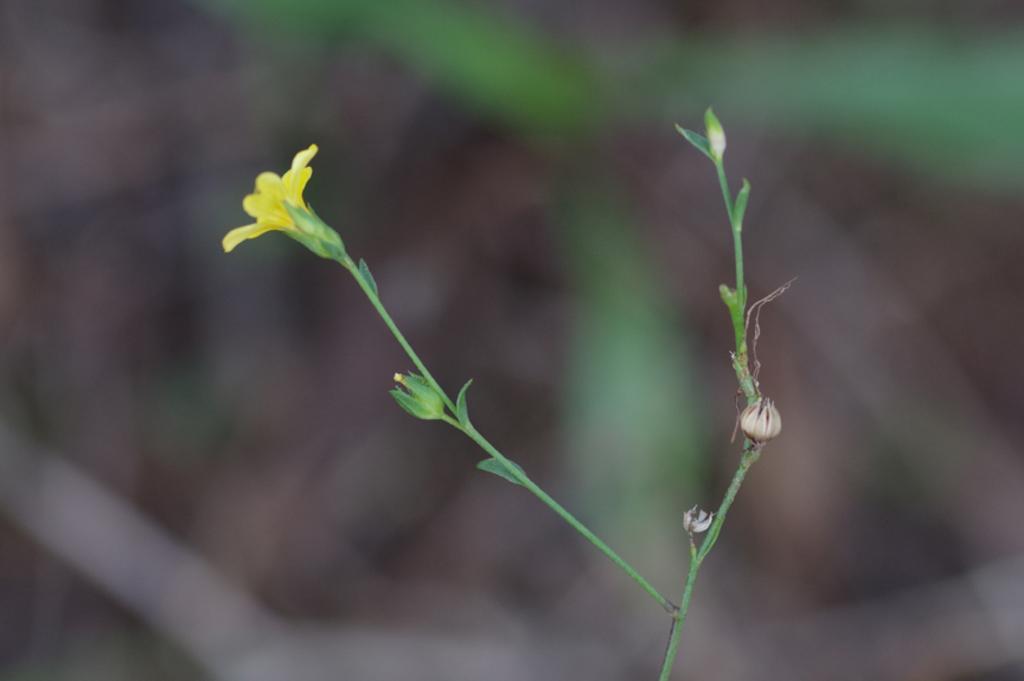Describe this image in one or two sentences. It is a flower which is in yellow color. 